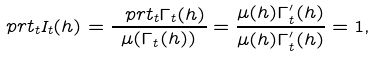<formula> <loc_0><loc_0><loc_500><loc_500>\ p r t _ { t } I _ { t } ( h ) = \frac { \ p r t _ { t } \Gamma _ { t } ( h ) } { \mu ( \Gamma _ { t } ( h ) ) } = \frac { \mu ( h ) \Gamma _ { t } ^ { \prime } ( h ) } { \mu ( h ) \Gamma _ { t } ^ { \prime } ( h ) } = 1 ,</formula> 